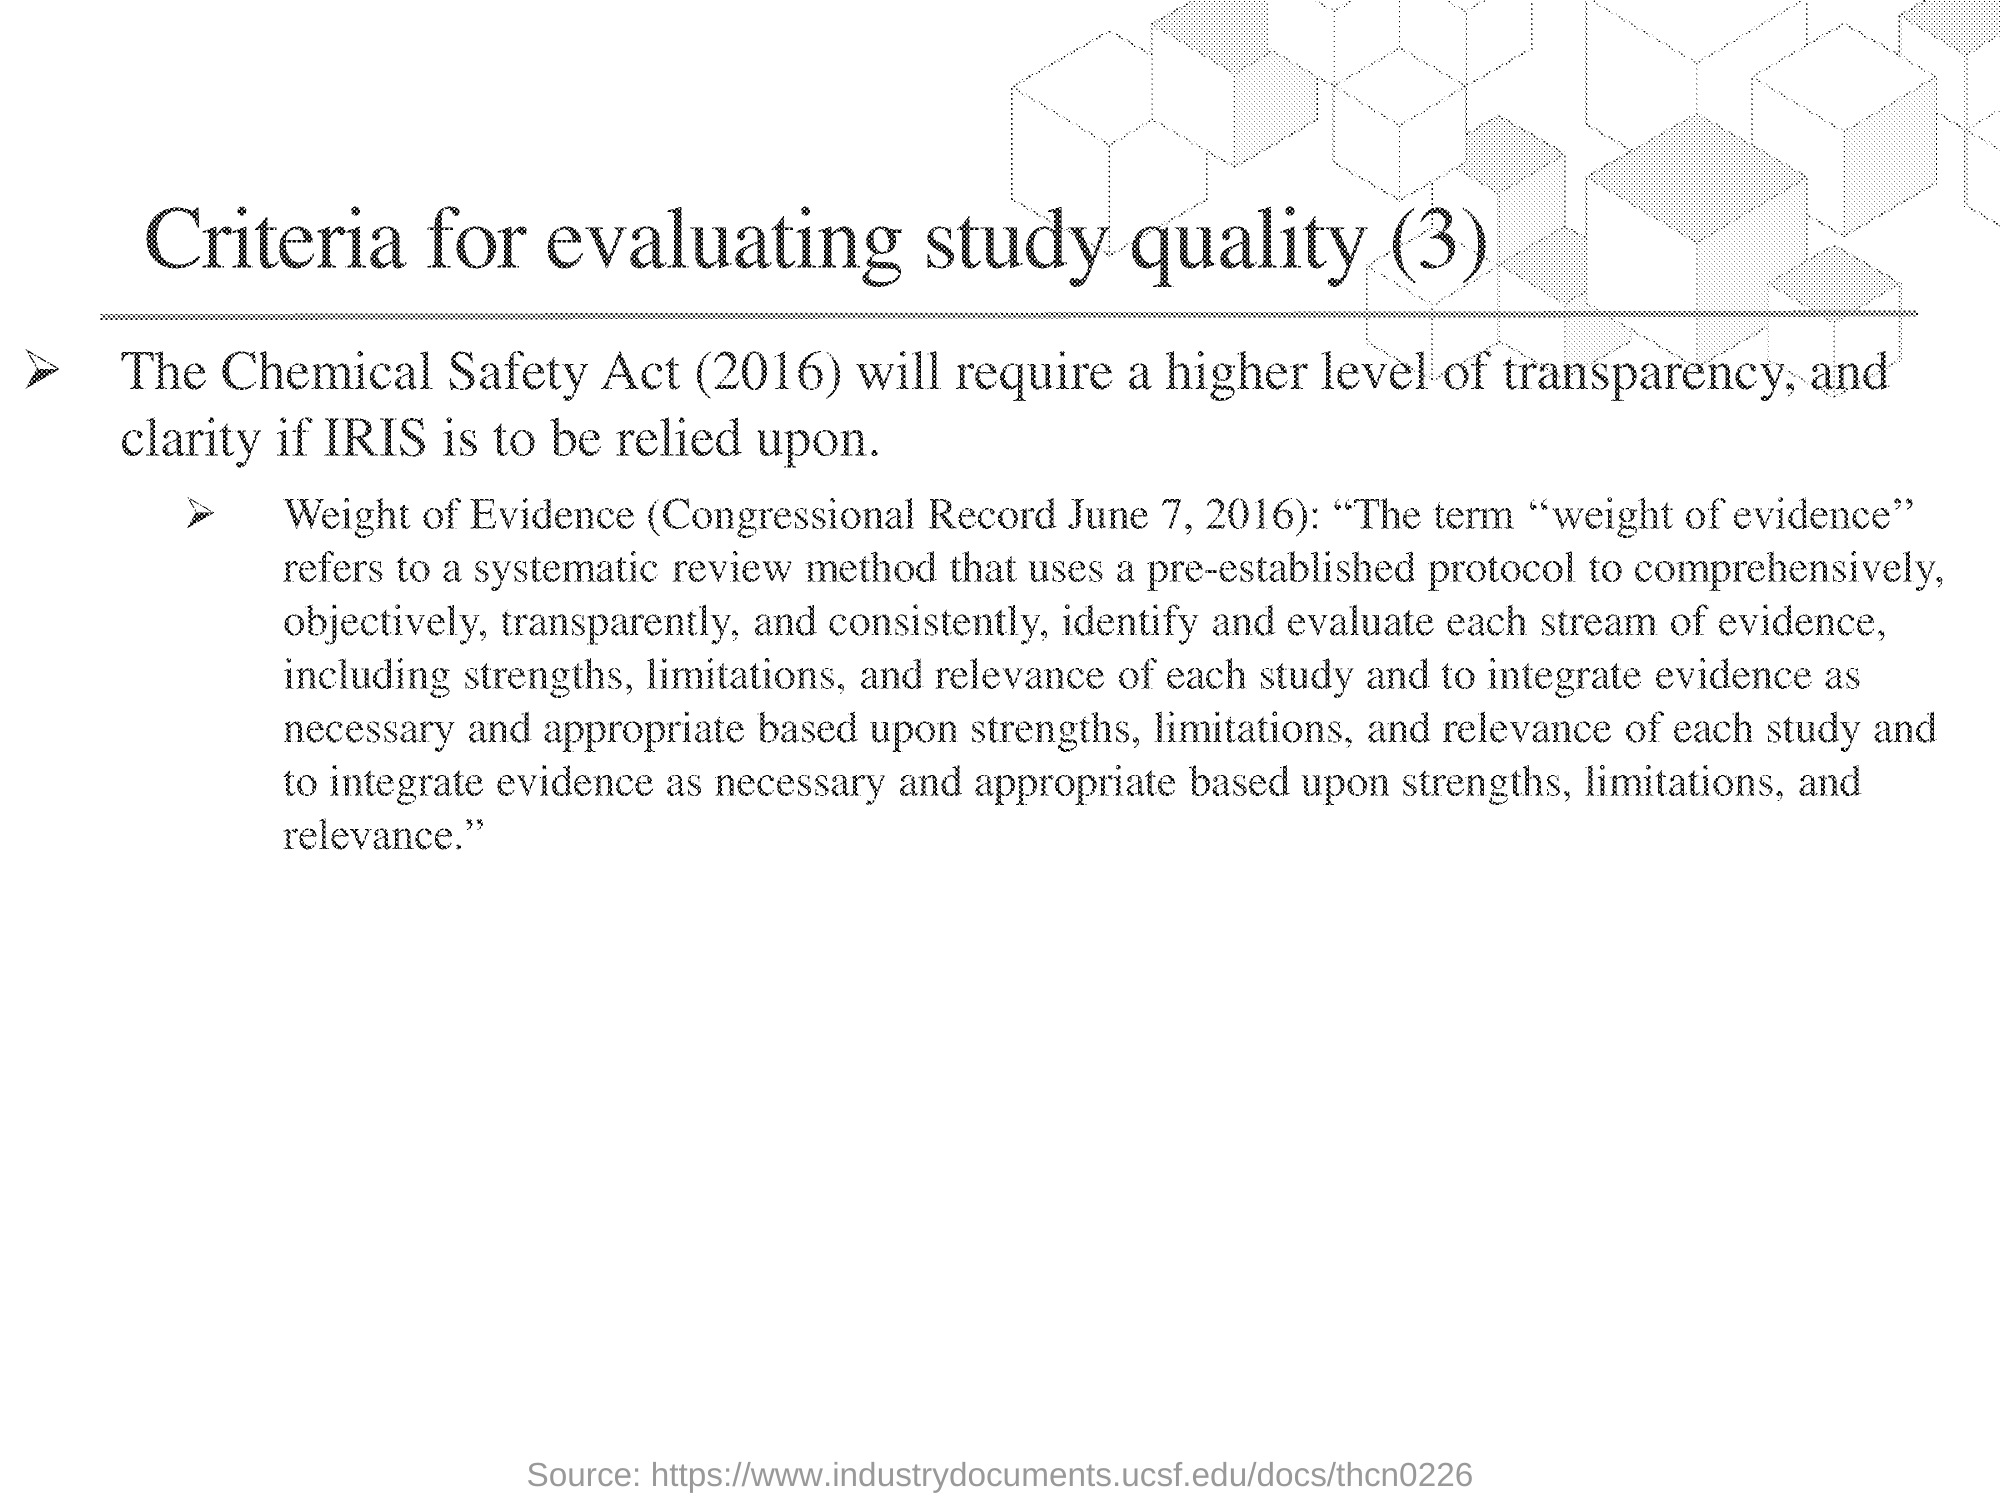What is the title of this document?
Your response must be concise. Criteria for evaluating study quality (3). 